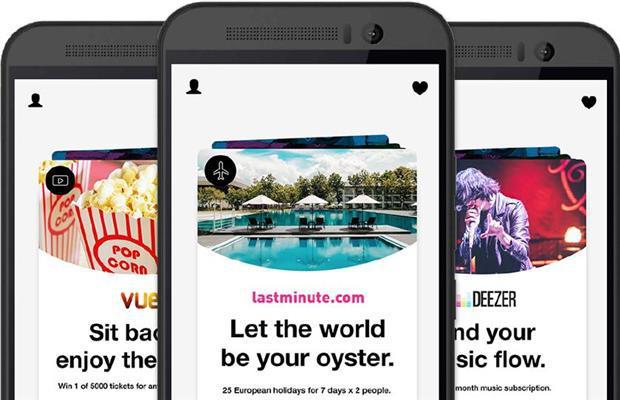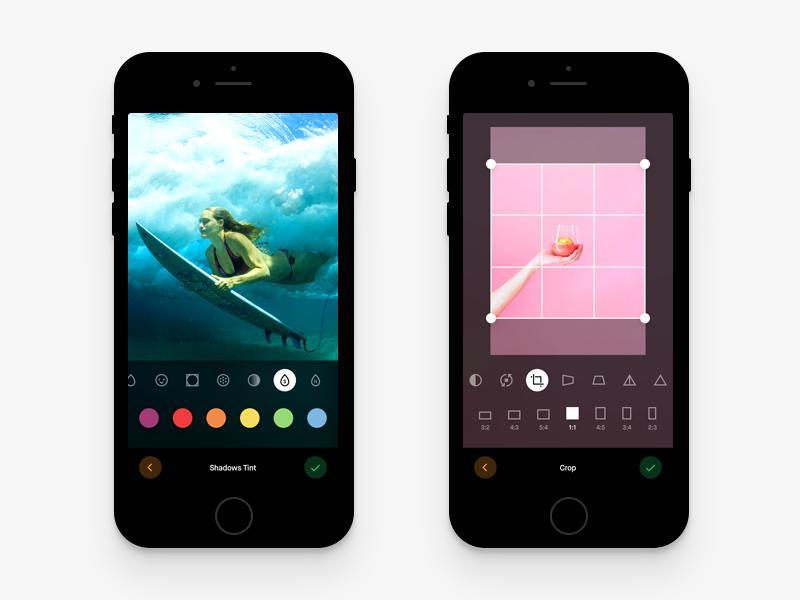The first image is the image on the left, the second image is the image on the right. For the images shown, is this caption "One of the images shows a cell phone that has three differently colored circles on the screen." true? Answer yes or no. No. The first image is the image on the left, the second image is the image on the right. For the images displayed, is the sentence "One image shows two side by side phones displayed screen-first and head-on, and the other image shows a row of three screen-first phones that are not overlapping." factually correct? Answer yes or no. No. 